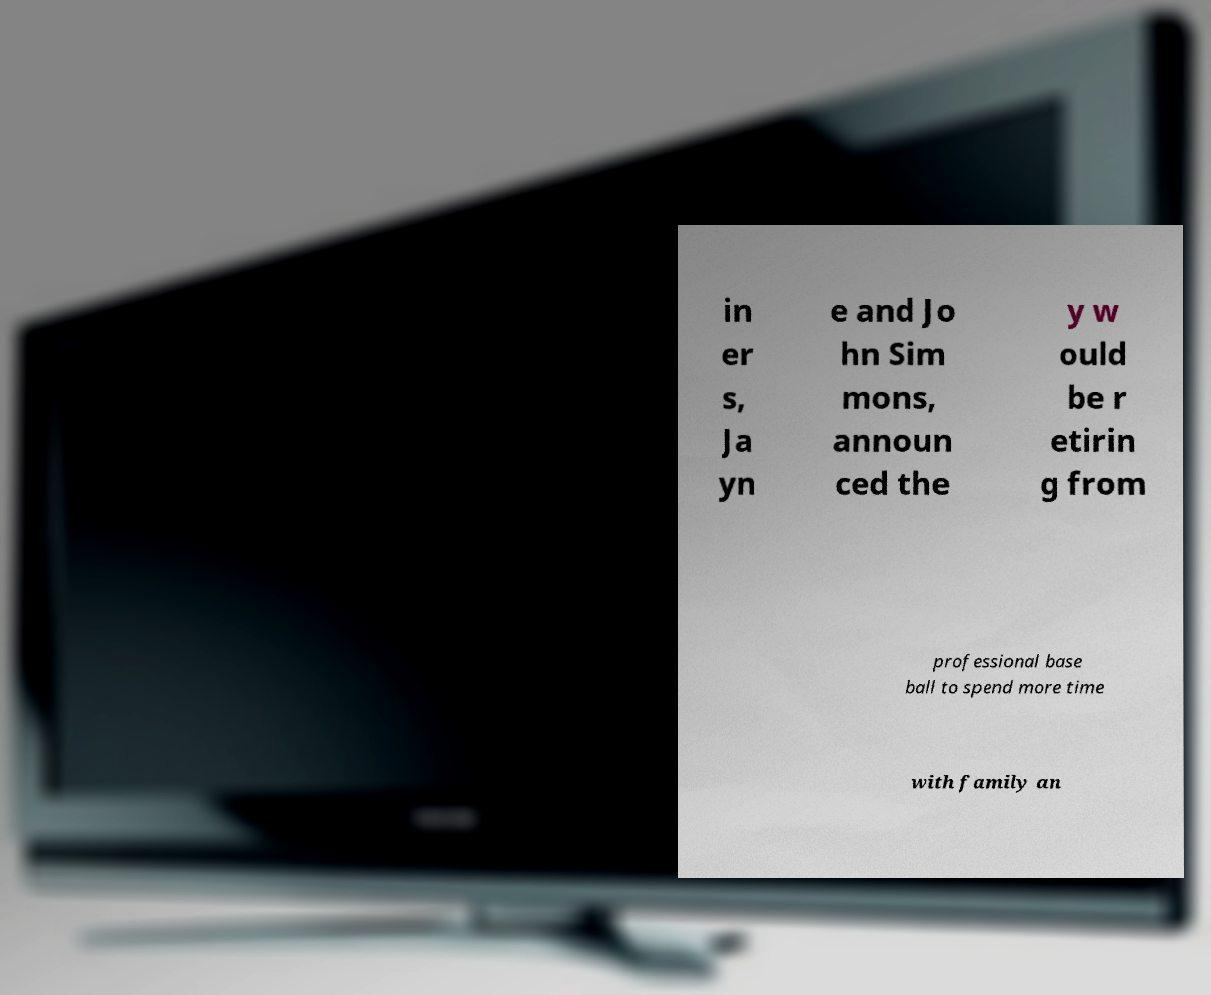Please identify and transcribe the text found in this image. in er s, Ja yn e and Jo hn Sim mons, announ ced the y w ould be r etirin g from professional base ball to spend more time with family an 